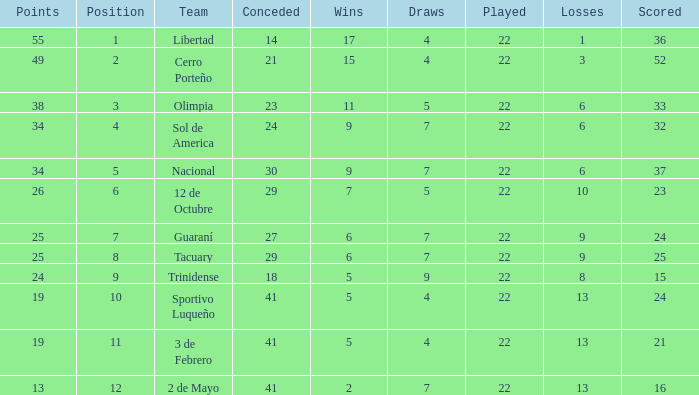What is the number of draws for the team with more than 8 losses and 13 points? 7.0. 